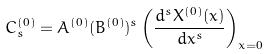<formula> <loc_0><loc_0><loc_500><loc_500>C ^ { ( 0 ) } _ { s } = A ^ { ( 0 ) } ( B ^ { ( 0 ) } ) ^ { s } \left ( \frac { d ^ { s } X ^ { ( 0 ) } ( x ) } { d x ^ { s } } \right ) _ { x = 0 }</formula> 